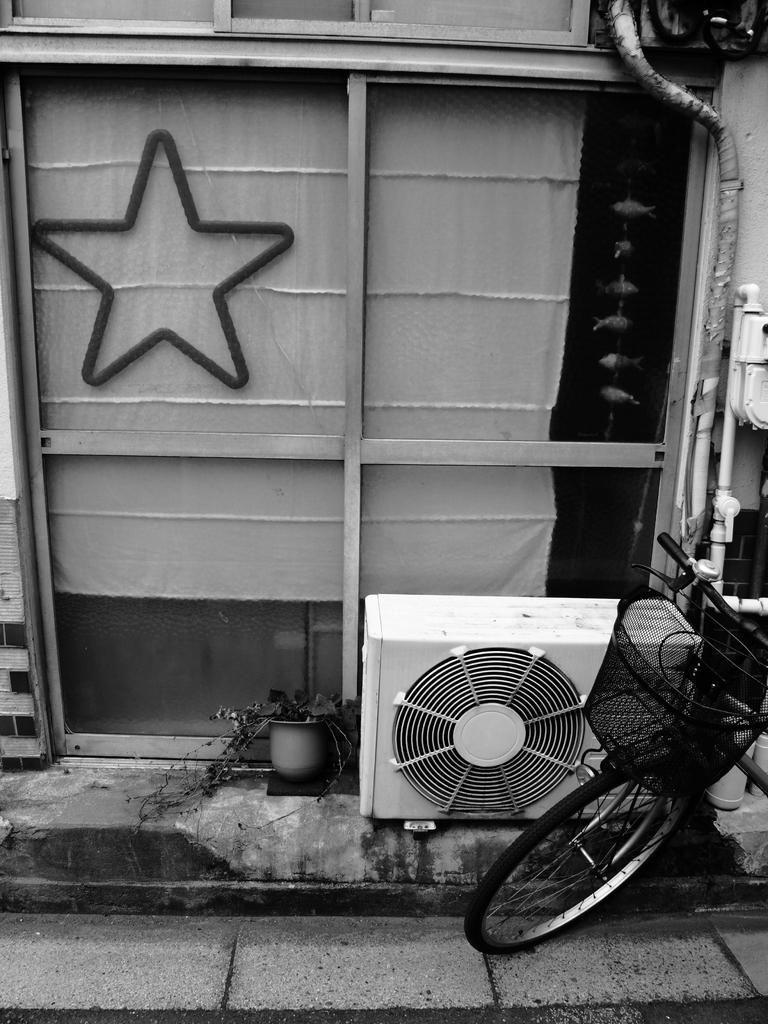How would you summarize this image in a sentence or two? On the right side of the image we can see a bicycle, few pipes and air conditioner outdoor unit, on the left side of the image we can find a star symbol on the glass, it is a black and white photograph. 